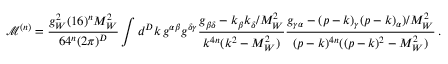<formula> <loc_0><loc_0><loc_500><loc_500>\mathcal { M } ^ { ( n ) } = \frac { g _ { W } ^ { 2 } ( 1 6 ) ^ { n } M _ { W } ^ { 2 } } { 6 4 ^ { n } ( 2 \pi ) ^ { D } } \int d ^ { D } k \, g ^ { \alpha \beta } g ^ { \delta \gamma } \frac { g _ { \beta \delta } - k _ { \beta } k _ { \delta } / M _ { W } ^ { 2 } } { k ^ { 4 n } ( k ^ { 2 } - M _ { W } ^ { 2 } ) } \frac { g _ { \gamma \alpha } - ( p - k ) _ { \gamma } ( p - k ) _ { \alpha } ) / M _ { W } ^ { 2 } } { ( p - k ) ^ { 4 n } ( ( p - k ) ^ { 2 } - M _ { W } ^ { 2 } ) } \, .</formula> 